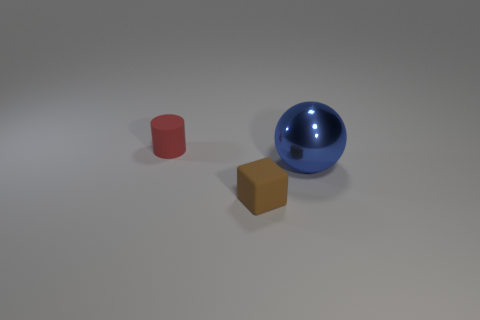Add 3 small purple rubber spheres. How many objects exist? 6 Subtract all cylinders. How many objects are left? 2 Subtract 0 red cubes. How many objects are left? 3 Subtract all rubber blocks. Subtract all small brown things. How many objects are left? 1 Add 3 large blue metal spheres. How many large blue metal spheres are left? 4 Add 2 tiny yellow balls. How many tiny yellow balls exist? 2 